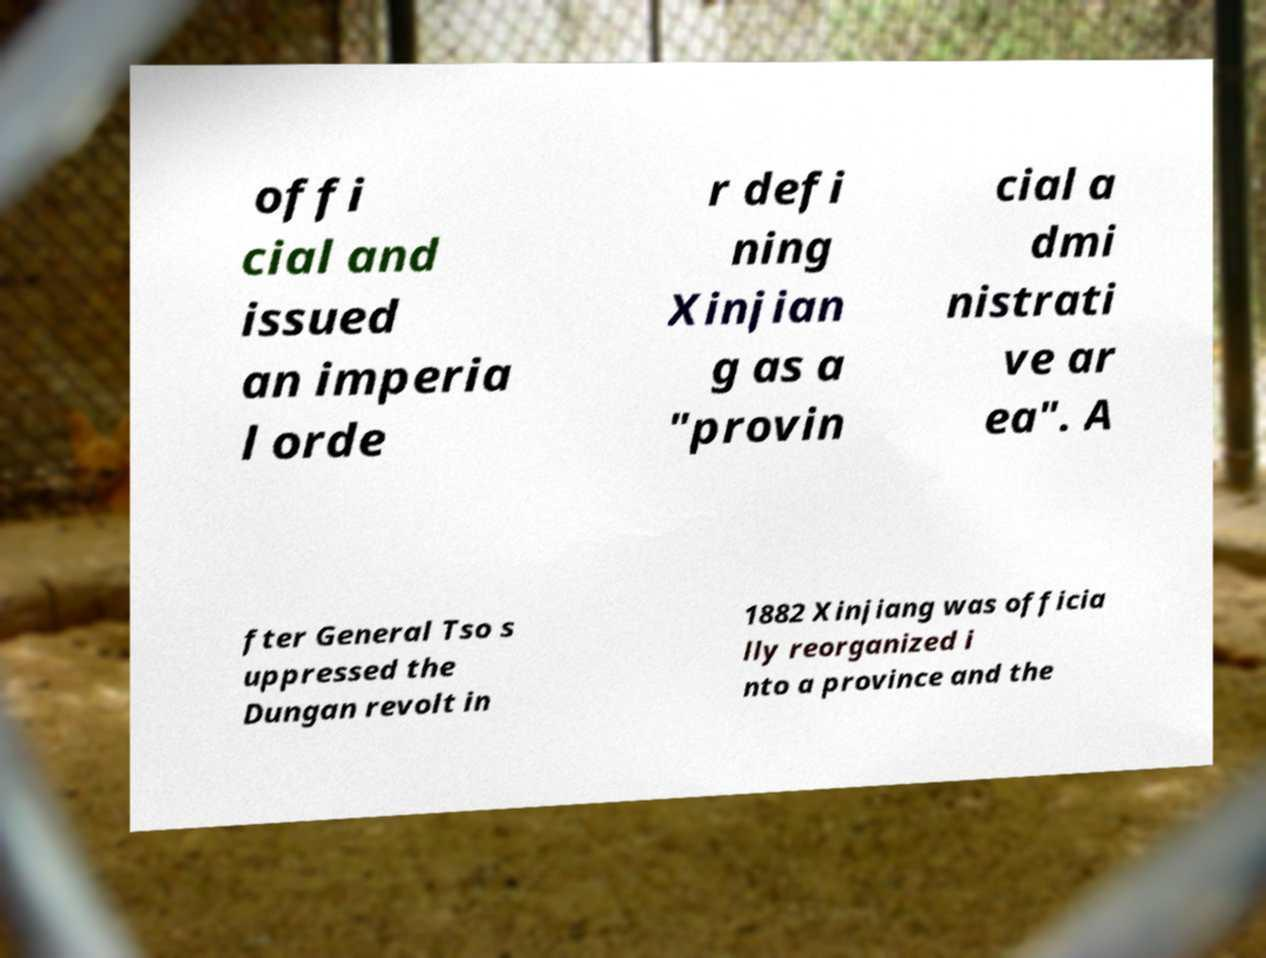There's text embedded in this image that I need extracted. Can you transcribe it verbatim? offi cial and issued an imperia l orde r defi ning Xinjian g as a "provin cial a dmi nistrati ve ar ea". A fter General Tso s uppressed the Dungan revolt in 1882 Xinjiang was officia lly reorganized i nto a province and the 